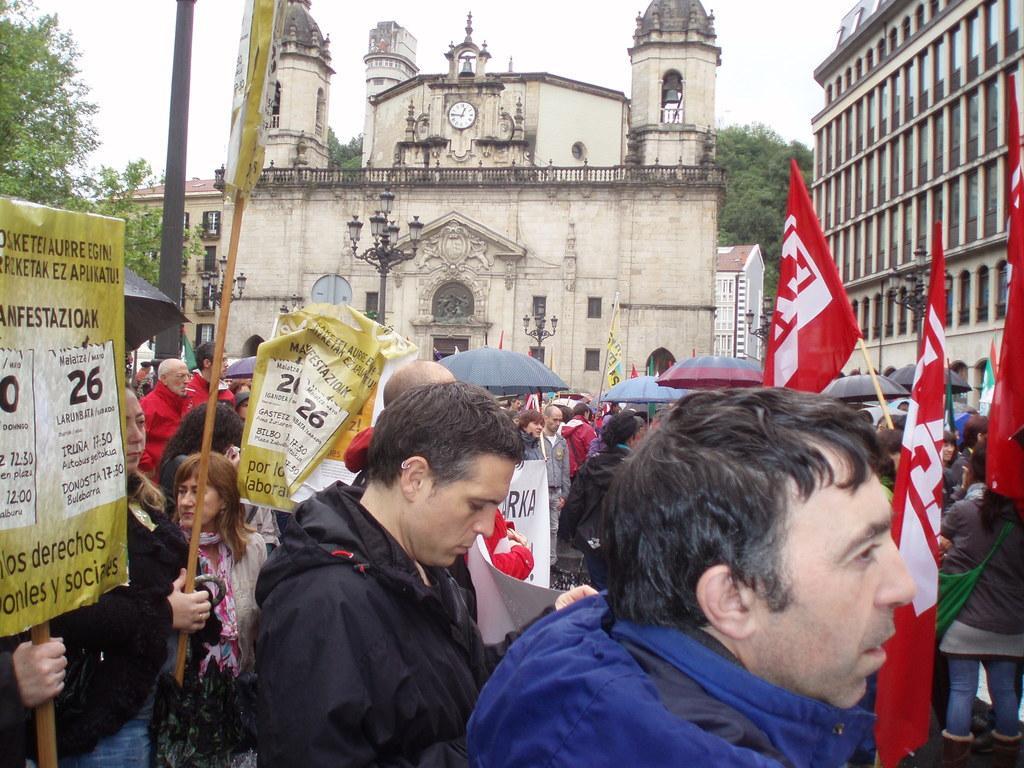Can you describe this image briefly? This image is clicked on the road. There are many people standing on the road. They are holding flags, placards and umbrellas in their hands. In the background there are buildings. There are street light poles in front of the buildings. There is a clock on the wall of the building. Behind the buildings there are trees. At the top there is the sky. 